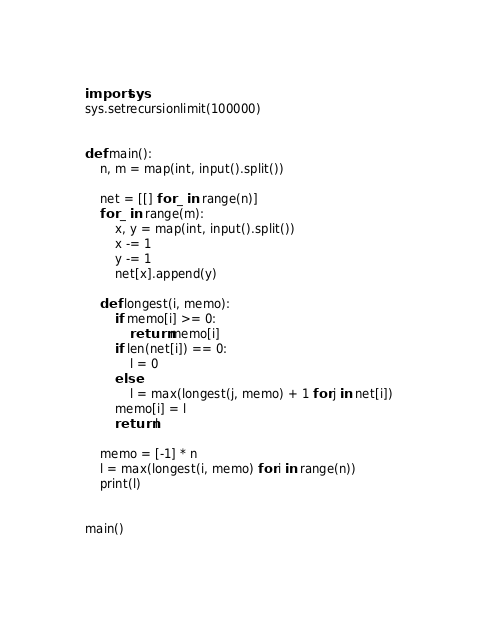<code> <loc_0><loc_0><loc_500><loc_500><_Python_>import sys
sys.setrecursionlimit(100000)


def main():
    n, m = map(int, input().split())

    net = [[] for _ in range(n)]
    for _ in range(m):
        x, y = map(int, input().split())
        x -= 1
        y -= 1
        net[x].append(y)

    def longest(i, memo):
        if memo[i] >= 0:
            return memo[i]
        if len(net[i]) == 0:
            l = 0
        else:
            l = max(longest(j, memo) + 1 for j in net[i])
        memo[i] = l
        return l

    memo = [-1] * n
    l = max(longest(i, memo) for i in range(n))
    print(l)


main()
</code> 